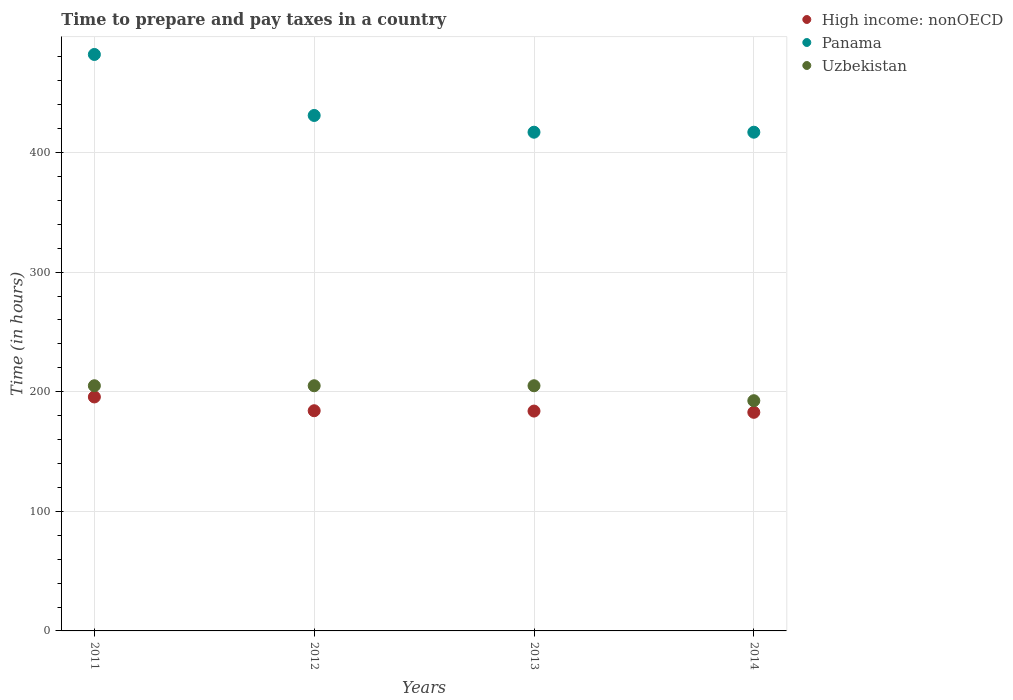How many different coloured dotlines are there?
Your answer should be compact. 3. Is the number of dotlines equal to the number of legend labels?
Keep it short and to the point. Yes. What is the number of hours required to prepare and pay taxes in Panama in 2014?
Provide a short and direct response. 417. Across all years, what is the maximum number of hours required to prepare and pay taxes in High income: nonOECD?
Provide a succinct answer. 195.63. Across all years, what is the minimum number of hours required to prepare and pay taxes in Panama?
Give a very brief answer. 417. In which year was the number of hours required to prepare and pay taxes in Uzbekistan maximum?
Ensure brevity in your answer.  2011. What is the total number of hours required to prepare and pay taxes in Uzbekistan in the graph?
Your answer should be very brief. 807.5. What is the difference between the number of hours required to prepare and pay taxes in Panama in 2011 and that in 2012?
Keep it short and to the point. 51. What is the difference between the number of hours required to prepare and pay taxes in High income: nonOECD in 2011 and the number of hours required to prepare and pay taxes in Uzbekistan in 2013?
Offer a very short reply. -9.37. What is the average number of hours required to prepare and pay taxes in Panama per year?
Make the answer very short. 436.75. In the year 2012, what is the difference between the number of hours required to prepare and pay taxes in Panama and number of hours required to prepare and pay taxes in High income: nonOECD?
Provide a succinct answer. 246.89. In how many years, is the number of hours required to prepare and pay taxes in Uzbekistan greater than 160 hours?
Make the answer very short. 4. What is the ratio of the number of hours required to prepare and pay taxes in Panama in 2011 to that in 2013?
Offer a very short reply. 1.16. What is the difference between the highest and the second highest number of hours required to prepare and pay taxes in High income: nonOECD?
Make the answer very short. 11.52. What is the difference between the highest and the lowest number of hours required to prepare and pay taxes in Panama?
Provide a short and direct response. 65. Does the number of hours required to prepare and pay taxes in High income: nonOECD monotonically increase over the years?
Ensure brevity in your answer.  No. Is the number of hours required to prepare and pay taxes in Panama strictly less than the number of hours required to prepare and pay taxes in Uzbekistan over the years?
Offer a terse response. No. How many dotlines are there?
Your answer should be compact. 3. How many years are there in the graph?
Provide a succinct answer. 4. What is the difference between two consecutive major ticks on the Y-axis?
Your answer should be very brief. 100. Does the graph contain any zero values?
Your answer should be compact. No. How many legend labels are there?
Provide a succinct answer. 3. What is the title of the graph?
Keep it short and to the point. Time to prepare and pay taxes in a country. Does "Trinidad and Tobago" appear as one of the legend labels in the graph?
Ensure brevity in your answer.  No. What is the label or title of the X-axis?
Your response must be concise. Years. What is the label or title of the Y-axis?
Offer a very short reply. Time (in hours). What is the Time (in hours) of High income: nonOECD in 2011?
Your answer should be very brief. 195.63. What is the Time (in hours) of Panama in 2011?
Offer a very short reply. 482. What is the Time (in hours) in Uzbekistan in 2011?
Provide a short and direct response. 205. What is the Time (in hours) of High income: nonOECD in 2012?
Ensure brevity in your answer.  184.11. What is the Time (in hours) of Panama in 2012?
Make the answer very short. 431. What is the Time (in hours) of Uzbekistan in 2012?
Your answer should be very brief. 205. What is the Time (in hours) in High income: nonOECD in 2013?
Provide a succinct answer. 183.82. What is the Time (in hours) in Panama in 2013?
Provide a short and direct response. 417. What is the Time (in hours) in Uzbekistan in 2013?
Make the answer very short. 205. What is the Time (in hours) in High income: nonOECD in 2014?
Keep it short and to the point. 182.79. What is the Time (in hours) in Panama in 2014?
Provide a short and direct response. 417. What is the Time (in hours) in Uzbekistan in 2014?
Provide a succinct answer. 192.5. Across all years, what is the maximum Time (in hours) of High income: nonOECD?
Provide a succinct answer. 195.63. Across all years, what is the maximum Time (in hours) in Panama?
Your answer should be compact. 482. Across all years, what is the maximum Time (in hours) of Uzbekistan?
Give a very brief answer. 205. Across all years, what is the minimum Time (in hours) of High income: nonOECD?
Provide a short and direct response. 182.79. Across all years, what is the minimum Time (in hours) in Panama?
Keep it short and to the point. 417. Across all years, what is the minimum Time (in hours) of Uzbekistan?
Ensure brevity in your answer.  192.5. What is the total Time (in hours) of High income: nonOECD in the graph?
Offer a terse response. 746.35. What is the total Time (in hours) in Panama in the graph?
Your answer should be compact. 1747. What is the total Time (in hours) of Uzbekistan in the graph?
Ensure brevity in your answer.  807.5. What is the difference between the Time (in hours) of High income: nonOECD in 2011 and that in 2012?
Give a very brief answer. 11.52. What is the difference between the Time (in hours) in Panama in 2011 and that in 2012?
Keep it short and to the point. 51. What is the difference between the Time (in hours) of Uzbekistan in 2011 and that in 2012?
Give a very brief answer. 0. What is the difference between the Time (in hours) of High income: nonOECD in 2011 and that in 2013?
Your response must be concise. 11.81. What is the difference between the Time (in hours) in Uzbekistan in 2011 and that in 2013?
Give a very brief answer. 0. What is the difference between the Time (in hours) in High income: nonOECD in 2011 and that in 2014?
Your answer should be compact. 12.85. What is the difference between the Time (in hours) of Panama in 2011 and that in 2014?
Give a very brief answer. 65. What is the difference between the Time (in hours) in Uzbekistan in 2011 and that in 2014?
Your answer should be very brief. 12.5. What is the difference between the Time (in hours) of High income: nonOECD in 2012 and that in 2013?
Your answer should be compact. 0.29. What is the difference between the Time (in hours) in Panama in 2012 and that in 2013?
Offer a very short reply. 14. What is the difference between the Time (in hours) in High income: nonOECD in 2012 and that in 2014?
Your answer should be compact. 1.33. What is the difference between the Time (in hours) of Panama in 2012 and that in 2014?
Make the answer very short. 14. What is the difference between the Time (in hours) in High income: nonOECD in 2013 and that in 2014?
Your answer should be compact. 1.04. What is the difference between the Time (in hours) of Uzbekistan in 2013 and that in 2014?
Keep it short and to the point. 12.5. What is the difference between the Time (in hours) of High income: nonOECD in 2011 and the Time (in hours) of Panama in 2012?
Your answer should be compact. -235.37. What is the difference between the Time (in hours) in High income: nonOECD in 2011 and the Time (in hours) in Uzbekistan in 2012?
Ensure brevity in your answer.  -9.37. What is the difference between the Time (in hours) of Panama in 2011 and the Time (in hours) of Uzbekistan in 2012?
Your answer should be very brief. 277. What is the difference between the Time (in hours) of High income: nonOECD in 2011 and the Time (in hours) of Panama in 2013?
Your answer should be very brief. -221.37. What is the difference between the Time (in hours) of High income: nonOECD in 2011 and the Time (in hours) of Uzbekistan in 2013?
Offer a terse response. -9.37. What is the difference between the Time (in hours) in Panama in 2011 and the Time (in hours) in Uzbekistan in 2013?
Give a very brief answer. 277. What is the difference between the Time (in hours) in High income: nonOECD in 2011 and the Time (in hours) in Panama in 2014?
Keep it short and to the point. -221.37. What is the difference between the Time (in hours) in High income: nonOECD in 2011 and the Time (in hours) in Uzbekistan in 2014?
Provide a succinct answer. 3.13. What is the difference between the Time (in hours) in Panama in 2011 and the Time (in hours) in Uzbekistan in 2014?
Give a very brief answer. 289.5. What is the difference between the Time (in hours) of High income: nonOECD in 2012 and the Time (in hours) of Panama in 2013?
Your answer should be very brief. -232.89. What is the difference between the Time (in hours) in High income: nonOECD in 2012 and the Time (in hours) in Uzbekistan in 2013?
Your answer should be very brief. -20.89. What is the difference between the Time (in hours) in Panama in 2012 and the Time (in hours) in Uzbekistan in 2013?
Ensure brevity in your answer.  226. What is the difference between the Time (in hours) in High income: nonOECD in 2012 and the Time (in hours) in Panama in 2014?
Provide a short and direct response. -232.89. What is the difference between the Time (in hours) in High income: nonOECD in 2012 and the Time (in hours) in Uzbekistan in 2014?
Give a very brief answer. -8.39. What is the difference between the Time (in hours) of Panama in 2012 and the Time (in hours) of Uzbekistan in 2014?
Keep it short and to the point. 238.5. What is the difference between the Time (in hours) in High income: nonOECD in 2013 and the Time (in hours) in Panama in 2014?
Provide a succinct answer. -233.18. What is the difference between the Time (in hours) in High income: nonOECD in 2013 and the Time (in hours) in Uzbekistan in 2014?
Keep it short and to the point. -8.68. What is the difference between the Time (in hours) in Panama in 2013 and the Time (in hours) in Uzbekistan in 2014?
Make the answer very short. 224.5. What is the average Time (in hours) in High income: nonOECD per year?
Your response must be concise. 186.59. What is the average Time (in hours) of Panama per year?
Provide a succinct answer. 436.75. What is the average Time (in hours) in Uzbekistan per year?
Provide a short and direct response. 201.88. In the year 2011, what is the difference between the Time (in hours) in High income: nonOECD and Time (in hours) in Panama?
Keep it short and to the point. -286.37. In the year 2011, what is the difference between the Time (in hours) in High income: nonOECD and Time (in hours) in Uzbekistan?
Offer a terse response. -9.37. In the year 2011, what is the difference between the Time (in hours) in Panama and Time (in hours) in Uzbekistan?
Ensure brevity in your answer.  277. In the year 2012, what is the difference between the Time (in hours) in High income: nonOECD and Time (in hours) in Panama?
Provide a short and direct response. -246.89. In the year 2012, what is the difference between the Time (in hours) of High income: nonOECD and Time (in hours) of Uzbekistan?
Your answer should be compact. -20.89. In the year 2012, what is the difference between the Time (in hours) in Panama and Time (in hours) in Uzbekistan?
Provide a succinct answer. 226. In the year 2013, what is the difference between the Time (in hours) of High income: nonOECD and Time (in hours) of Panama?
Provide a short and direct response. -233.18. In the year 2013, what is the difference between the Time (in hours) in High income: nonOECD and Time (in hours) in Uzbekistan?
Offer a terse response. -21.18. In the year 2013, what is the difference between the Time (in hours) in Panama and Time (in hours) in Uzbekistan?
Give a very brief answer. 212. In the year 2014, what is the difference between the Time (in hours) in High income: nonOECD and Time (in hours) in Panama?
Offer a terse response. -234.21. In the year 2014, what is the difference between the Time (in hours) of High income: nonOECD and Time (in hours) of Uzbekistan?
Provide a succinct answer. -9.71. In the year 2014, what is the difference between the Time (in hours) in Panama and Time (in hours) in Uzbekistan?
Offer a terse response. 224.5. What is the ratio of the Time (in hours) of High income: nonOECD in 2011 to that in 2012?
Make the answer very short. 1.06. What is the ratio of the Time (in hours) in Panama in 2011 to that in 2012?
Make the answer very short. 1.12. What is the ratio of the Time (in hours) in High income: nonOECD in 2011 to that in 2013?
Offer a terse response. 1.06. What is the ratio of the Time (in hours) in Panama in 2011 to that in 2013?
Give a very brief answer. 1.16. What is the ratio of the Time (in hours) of Uzbekistan in 2011 to that in 2013?
Your response must be concise. 1. What is the ratio of the Time (in hours) in High income: nonOECD in 2011 to that in 2014?
Make the answer very short. 1.07. What is the ratio of the Time (in hours) of Panama in 2011 to that in 2014?
Provide a succinct answer. 1.16. What is the ratio of the Time (in hours) of Uzbekistan in 2011 to that in 2014?
Give a very brief answer. 1.06. What is the ratio of the Time (in hours) in High income: nonOECD in 2012 to that in 2013?
Offer a very short reply. 1. What is the ratio of the Time (in hours) in Panama in 2012 to that in 2013?
Keep it short and to the point. 1.03. What is the ratio of the Time (in hours) in High income: nonOECD in 2012 to that in 2014?
Your response must be concise. 1.01. What is the ratio of the Time (in hours) in Panama in 2012 to that in 2014?
Keep it short and to the point. 1.03. What is the ratio of the Time (in hours) in Uzbekistan in 2012 to that in 2014?
Provide a short and direct response. 1.06. What is the ratio of the Time (in hours) in Panama in 2013 to that in 2014?
Your answer should be compact. 1. What is the ratio of the Time (in hours) in Uzbekistan in 2013 to that in 2014?
Keep it short and to the point. 1.06. What is the difference between the highest and the second highest Time (in hours) in High income: nonOECD?
Keep it short and to the point. 11.52. What is the difference between the highest and the second highest Time (in hours) in Panama?
Your answer should be very brief. 51. What is the difference between the highest and the lowest Time (in hours) in High income: nonOECD?
Offer a very short reply. 12.85. 